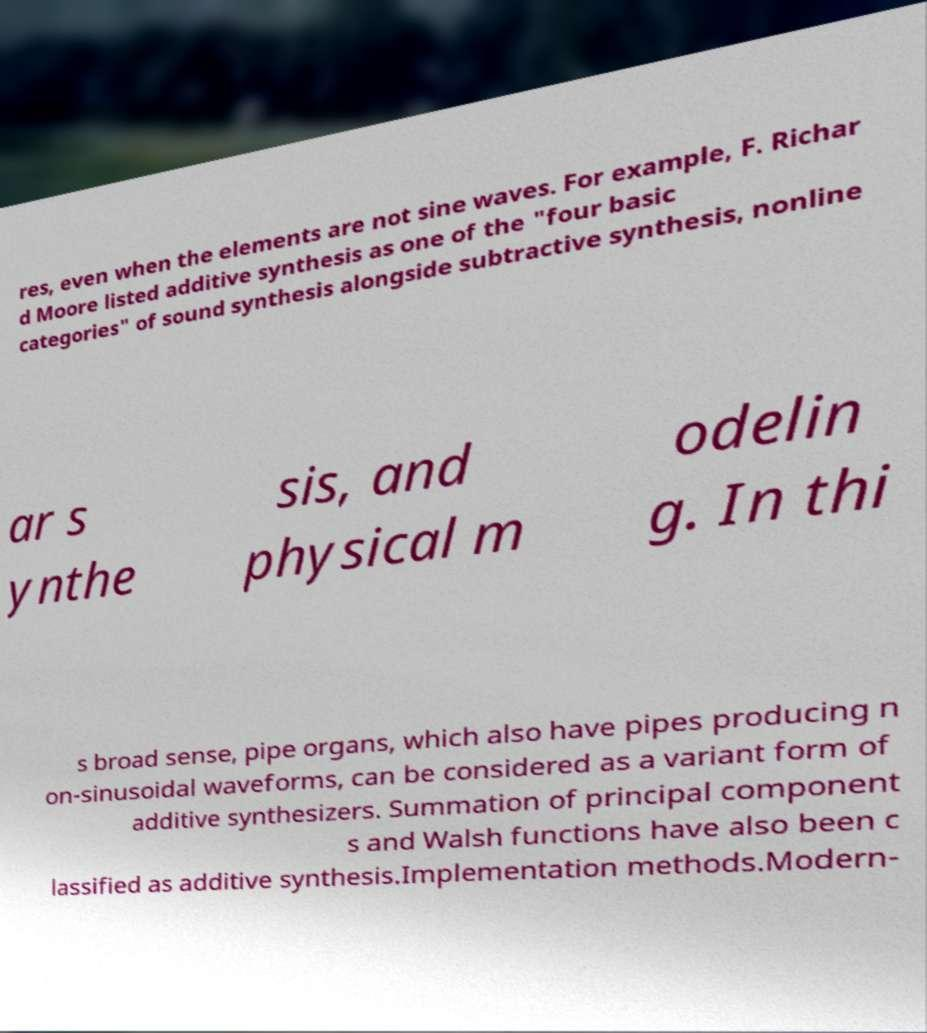What messages or text are displayed in this image? I need them in a readable, typed format. res, even when the elements are not sine waves. For example, F. Richar d Moore listed additive synthesis as one of the "four basic categories" of sound synthesis alongside subtractive synthesis, nonline ar s ynthe sis, and physical m odelin g. In thi s broad sense, pipe organs, which also have pipes producing n on-sinusoidal waveforms, can be considered as a variant form of additive synthesizers. Summation of principal component s and Walsh functions have also been c lassified as additive synthesis.Implementation methods.Modern- 